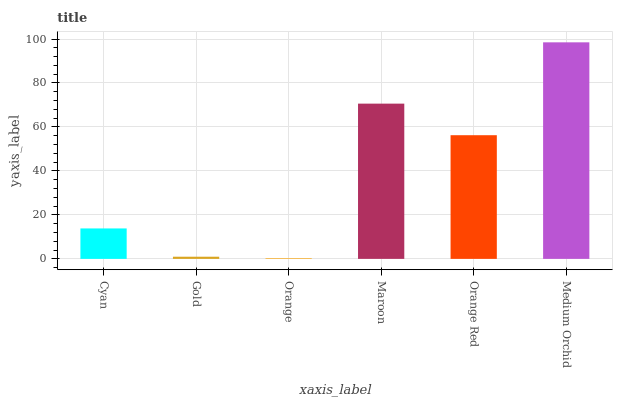Is Gold the minimum?
Answer yes or no. No. Is Gold the maximum?
Answer yes or no. No. Is Cyan greater than Gold?
Answer yes or no. Yes. Is Gold less than Cyan?
Answer yes or no. Yes. Is Gold greater than Cyan?
Answer yes or no. No. Is Cyan less than Gold?
Answer yes or no. No. Is Orange Red the high median?
Answer yes or no. Yes. Is Cyan the low median?
Answer yes or no. Yes. Is Maroon the high median?
Answer yes or no. No. Is Gold the low median?
Answer yes or no. No. 